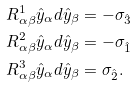Convert formula to latex. <formula><loc_0><loc_0><loc_500><loc_500>R _ { \alpha \beta } ^ { 1 } \hat { y } _ { \alpha } d \hat { y } _ { \beta } & = - \sigma _ { \hat { 3 } } \\ R _ { \alpha \beta } ^ { 2 } \hat { y } _ { \alpha } d \hat { y } _ { \beta } & = - \sigma _ { \hat { 1 } } \\ R _ { \alpha \beta } ^ { 3 } \hat { y } _ { \alpha } d \hat { y } _ { \beta } & = \sigma _ { \hat { 2 } } .</formula> 